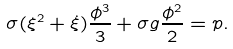<formula> <loc_0><loc_0><loc_500><loc_500>\sigma ( \xi ^ { 2 } + \dot { \xi } ) \frac { \phi ^ { 3 } } { 3 } + \sigma g \frac { \phi ^ { 2 } } { 2 } = p .</formula> 